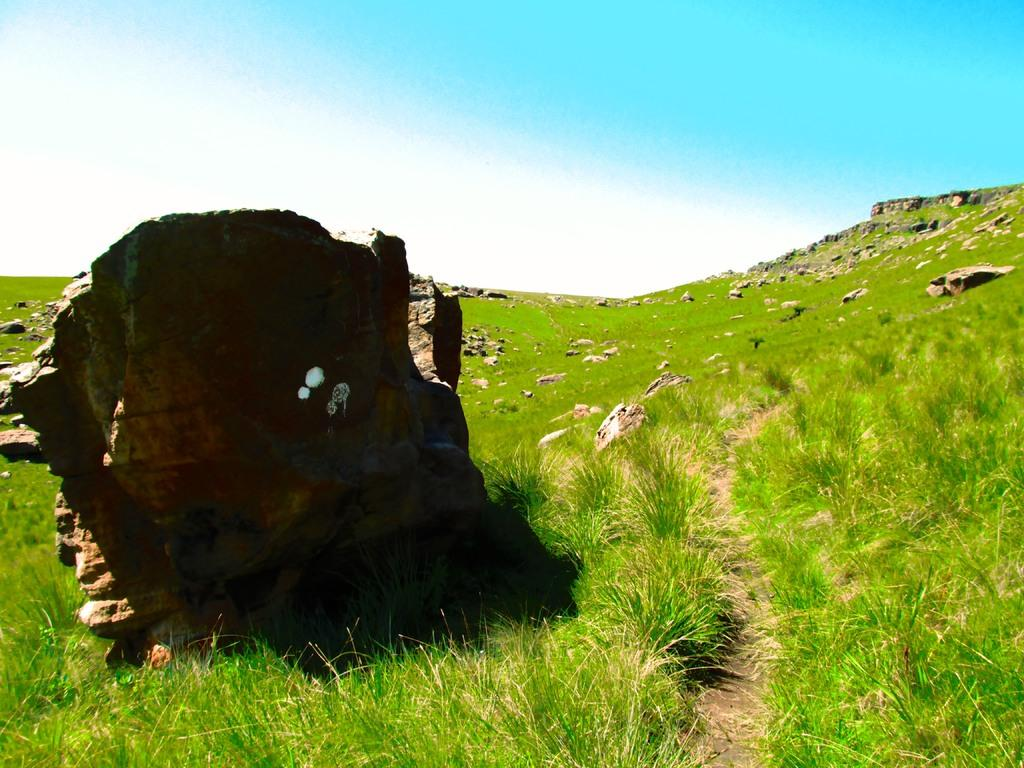What type of terrain is visible in the image? There are rocks on the grassland in the image. What can be seen in the sky in the image? The sky is visible at the top of the image. What hobbies are being practiced on the dock in the image? There is no dock present in the image; it features rocks on a grassland. Can you provide an example of a rock formation in the image? There is no need to provide an example of a rock formation in the image, as the fact states that there are rocks on the grassland. 